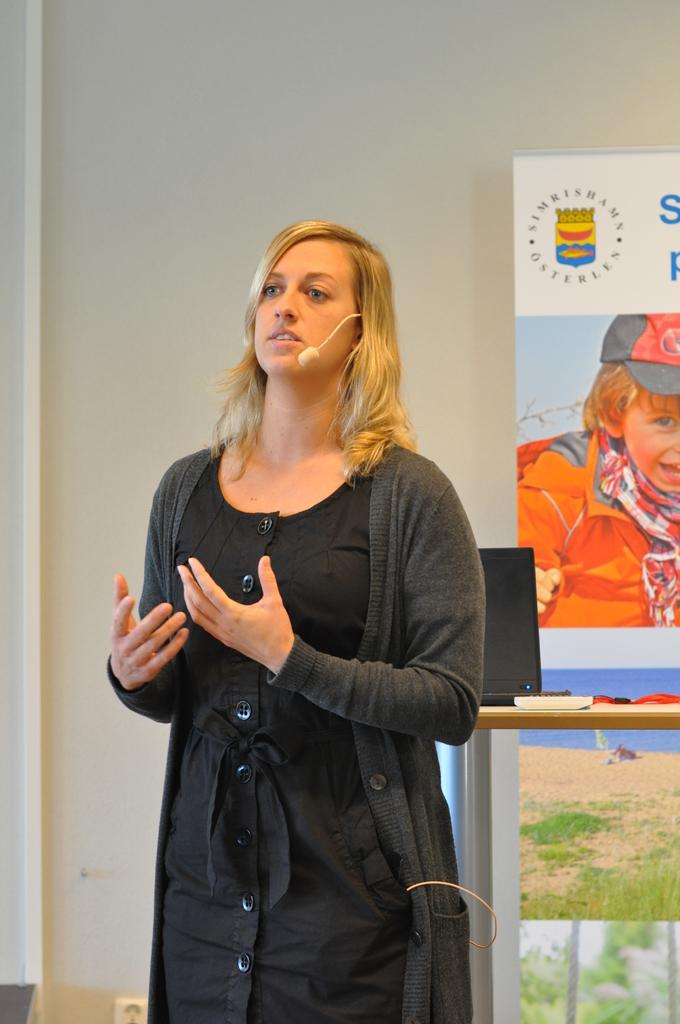What can be seen in the background of the image? There is a wall, a board, and other objects in the background of the image. What is the woman in the image wearing? The woman is wearing a black dress. What is the woman holding in the image? The woman is holding a microphone. What might the woman be doing in the image? The woman appears to be talking, and she is holding a microphone, which suggests she might be giving a speech or presentation. What is the woman's posture in the image? The woman is standing in the image. How many balloons are floating above the woman's head in the image? There are no balloons visible in the image. What type of basin is being used by the woman in the image? There is no basin present in the image. 